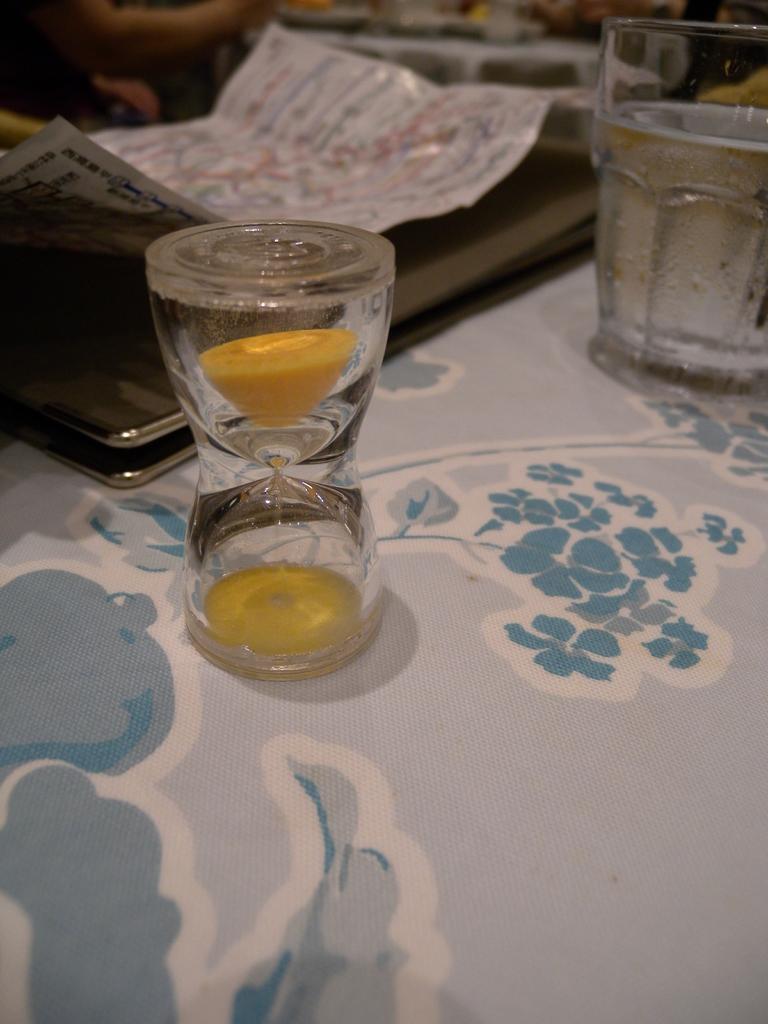Please provide a concise description of this image. In the image there is a sand timer, behind that there is some other object and on the right side there is a glass with some drink. 